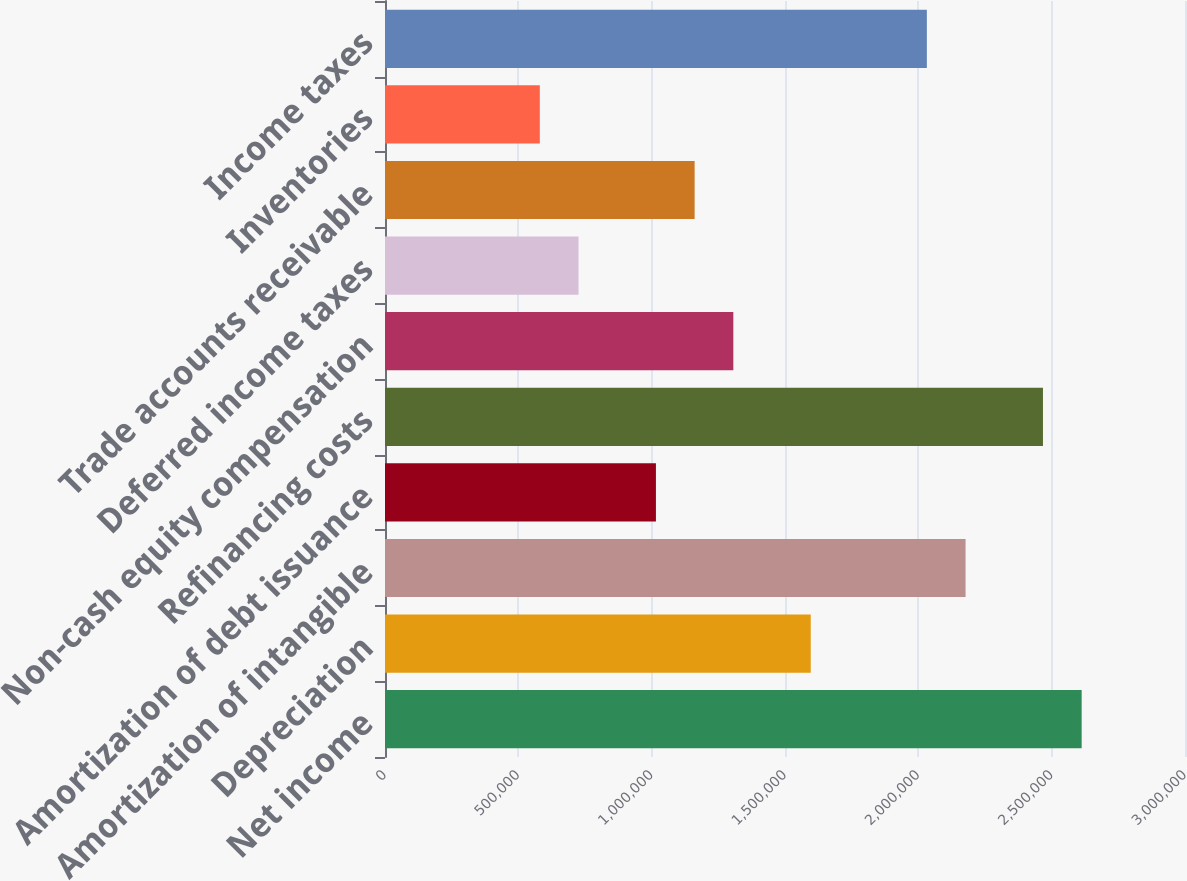Convert chart to OTSL. <chart><loc_0><loc_0><loc_500><loc_500><bar_chart><fcel>Net income<fcel>Depreciation<fcel>Amortization of intangible<fcel>Amortization of debt issuance<fcel>Refinancing costs<fcel>Non-cash equity compensation<fcel>Deferred income taxes<fcel>Trade accounts receivable<fcel>Inventories<fcel>Income taxes<nl><fcel>2.61248e+06<fcel>1.59653e+06<fcel>2.17707e+06<fcel>1.01598e+06<fcel>2.46735e+06<fcel>1.30625e+06<fcel>725709<fcel>1.16112e+06<fcel>580573<fcel>2.03194e+06<nl></chart> 